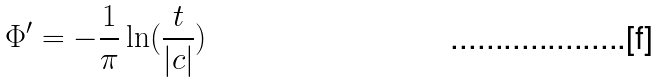<formula> <loc_0><loc_0><loc_500><loc_500>\Phi ^ { \prime } = - \frac { 1 } { \pi } \ln ( \frac { t } { | c | } )</formula> 